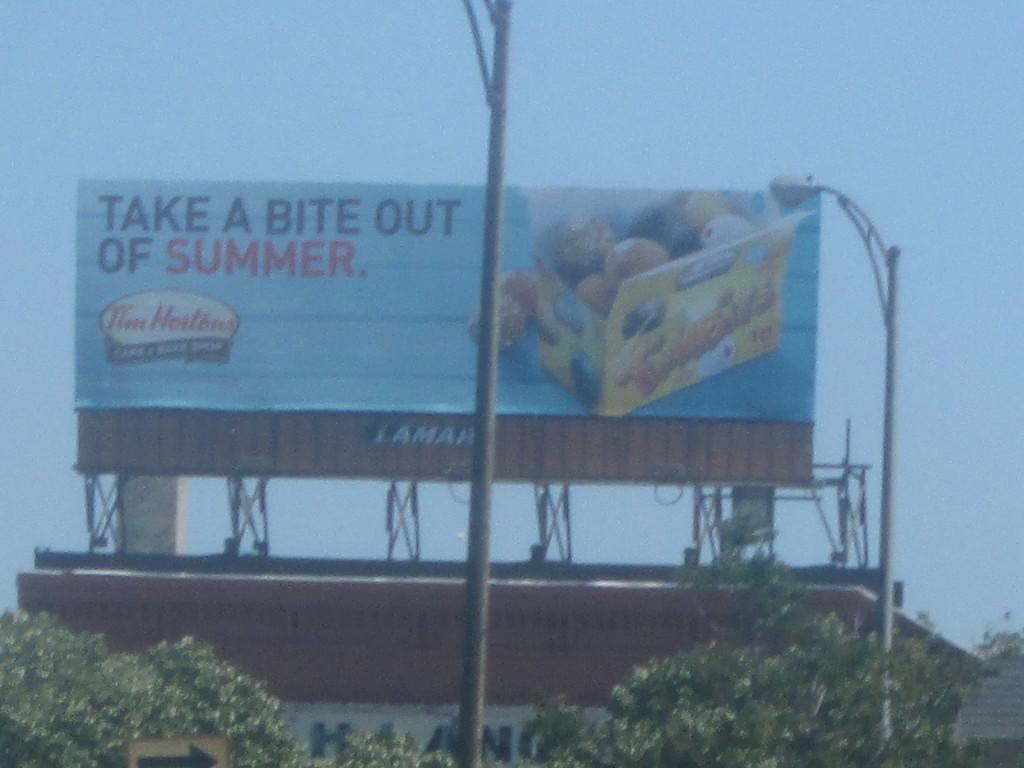Provide a one-sentence caption for the provided image. A big billboard for tim hortons that says to take a bite out of summer. 